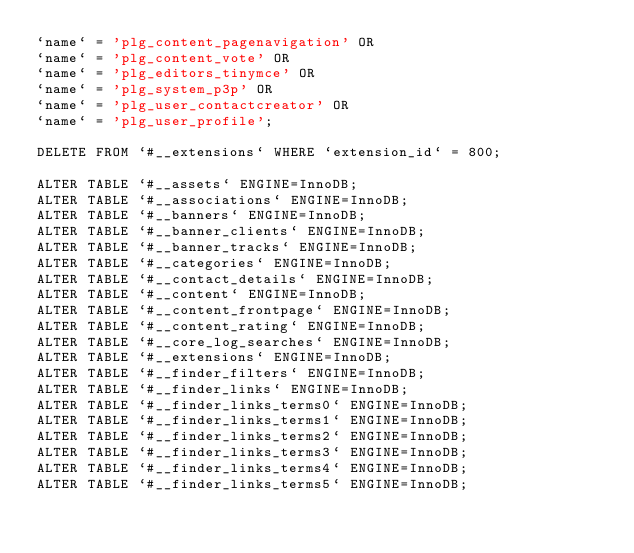Convert code to text. <code><loc_0><loc_0><loc_500><loc_500><_SQL_>`name` = 'plg_content_pagenavigation' OR
`name` = 'plg_content_vote' OR
`name` = 'plg_editors_tinymce' OR
`name` = 'plg_system_p3p' OR
`name` = 'plg_user_contactcreator' OR
`name` = 'plg_user_profile';

DELETE FROM `#__extensions` WHERE `extension_id` = 800;

ALTER TABLE `#__assets` ENGINE=InnoDB;
ALTER TABLE `#__associations` ENGINE=InnoDB;
ALTER TABLE `#__banners` ENGINE=InnoDB;
ALTER TABLE `#__banner_clients` ENGINE=InnoDB;
ALTER TABLE `#__banner_tracks` ENGINE=InnoDB;
ALTER TABLE `#__categories` ENGINE=InnoDB;
ALTER TABLE `#__contact_details` ENGINE=InnoDB;
ALTER TABLE `#__content` ENGINE=InnoDB;
ALTER TABLE `#__content_frontpage` ENGINE=InnoDB;
ALTER TABLE `#__content_rating` ENGINE=InnoDB;
ALTER TABLE `#__core_log_searches` ENGINE=InnoDB;
ALTER TABLE `#__extensions` ENGINE=InnoDB;
ALTER TABLE `#__finder_filters` ENGINE=InnoDB;
ALTER TABLE `#__finder_links` ENGINE=InnoDB;
ALTER TABLE `#__finder_links_terms0` ENGINE=InnoDB;
ALTER TABLE `#__finder_links_terms1` ENGINE=InnoDB;
ALTER TABLE `#__finder_links_terms2` ENGINE=InnoDB;
ALTER TABLE `#__finder_links_terms3` ENGINE=InnoDB;
ALTER TABLE `#__finder_links_terms4` ENGINE=InnoDB;
ALTER TABLE `#__finder_links_terms5` ENGINE=InnoDB;</code> 